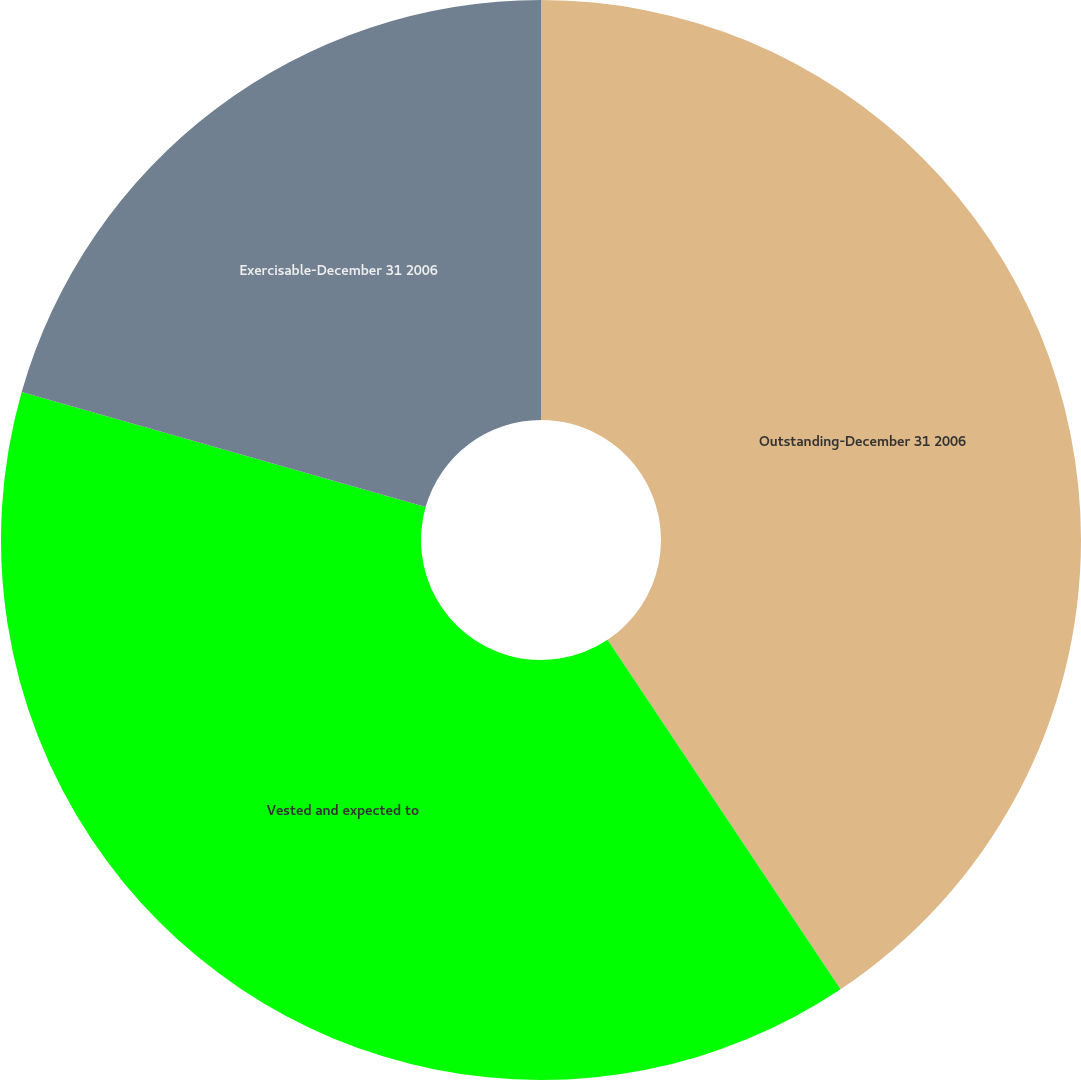<chart> <loc_0><loc_0><loc_500><loc_500><pie_chart><fcel>Outstanding-December 31 2006<fcel>Vested and expected to<fcel>Exercisable-December 31 2006<nl><fcel>40.64%<fcel>38.78%<fcel>20.58%<nl></chart> 